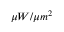<formula> <loc_0><loc_0><loc_500><loc_500>\mu W / { \mu m } ^ { 2 }</formula> 